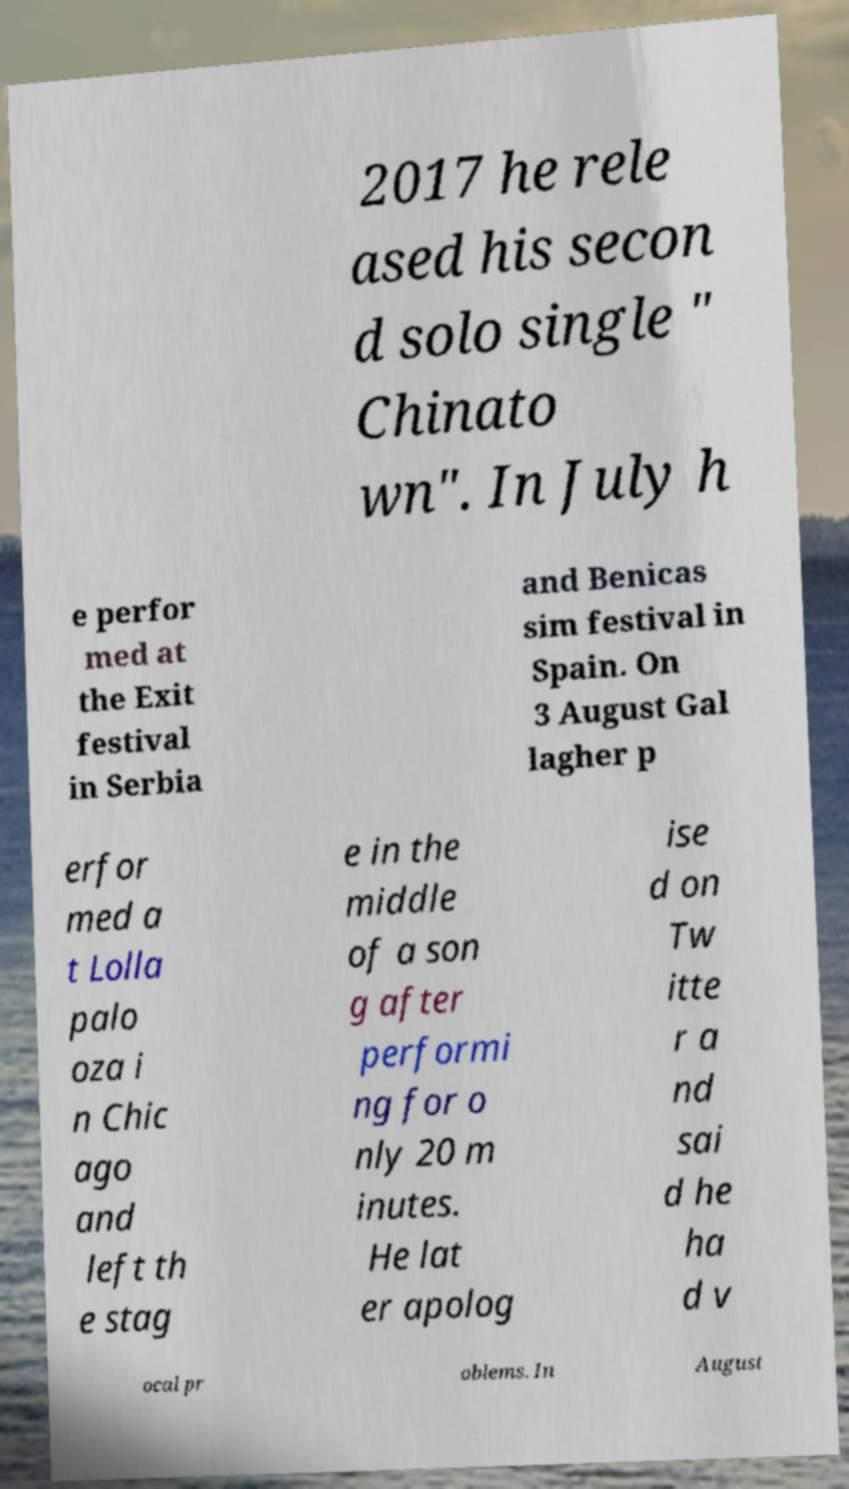There's text embedded in this image that I need extracted. Can you transcribe it verbatim? 2017 he rele ased his secon d solo single " Chinato wn". In July h e perfor med at the Exit festival in Serbia and Benicas sim festival in Spain. On 3 August Gal lagher p erfor med a t Lolla palo oza i n Chic ago and left th e stag e in the middle of a son g after performi ng for o nly 20 m inutes. He lat er apolog ise d on Tw itte r a nd sai d he ha d v ocal pr oblems. In August 